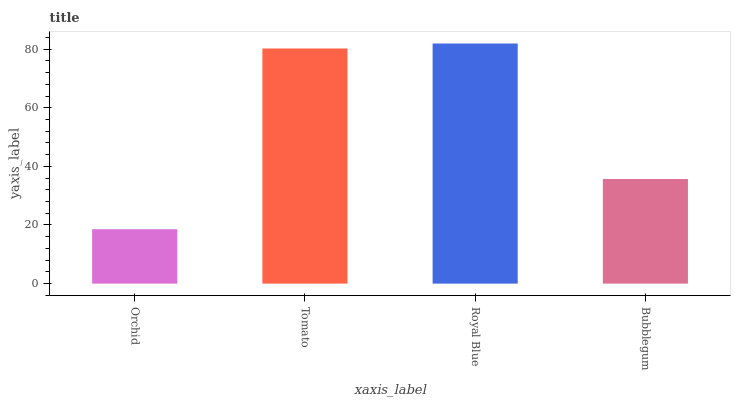Is Orchid the minimum?
Answer yes or no. Yes. Is Royal Blue the maximum?
Answer yes or no. Yes. Is Tomato the minimum?
Answer yes or no. No. Is Tomato the maximum?
Answer yes or no. No. Is Tomato greater than Orchid?
Answer yes or no. Yes. Is Orchid less than Tomato?
Answer yes or no. Yes. Is Orchid greater than Tomato?
Answer yes or no. No. Is Tomato less than Orchid?
Answer yes or no. No. Is Tomato the high median?
Answer yes or no. Yes. Is Bubblegum the low median?
Answer yes or no. Yes. Is Orchid the high median?
Answer yes or no. No. Is Royal Blue the low median?
Answer yes or no. No. 